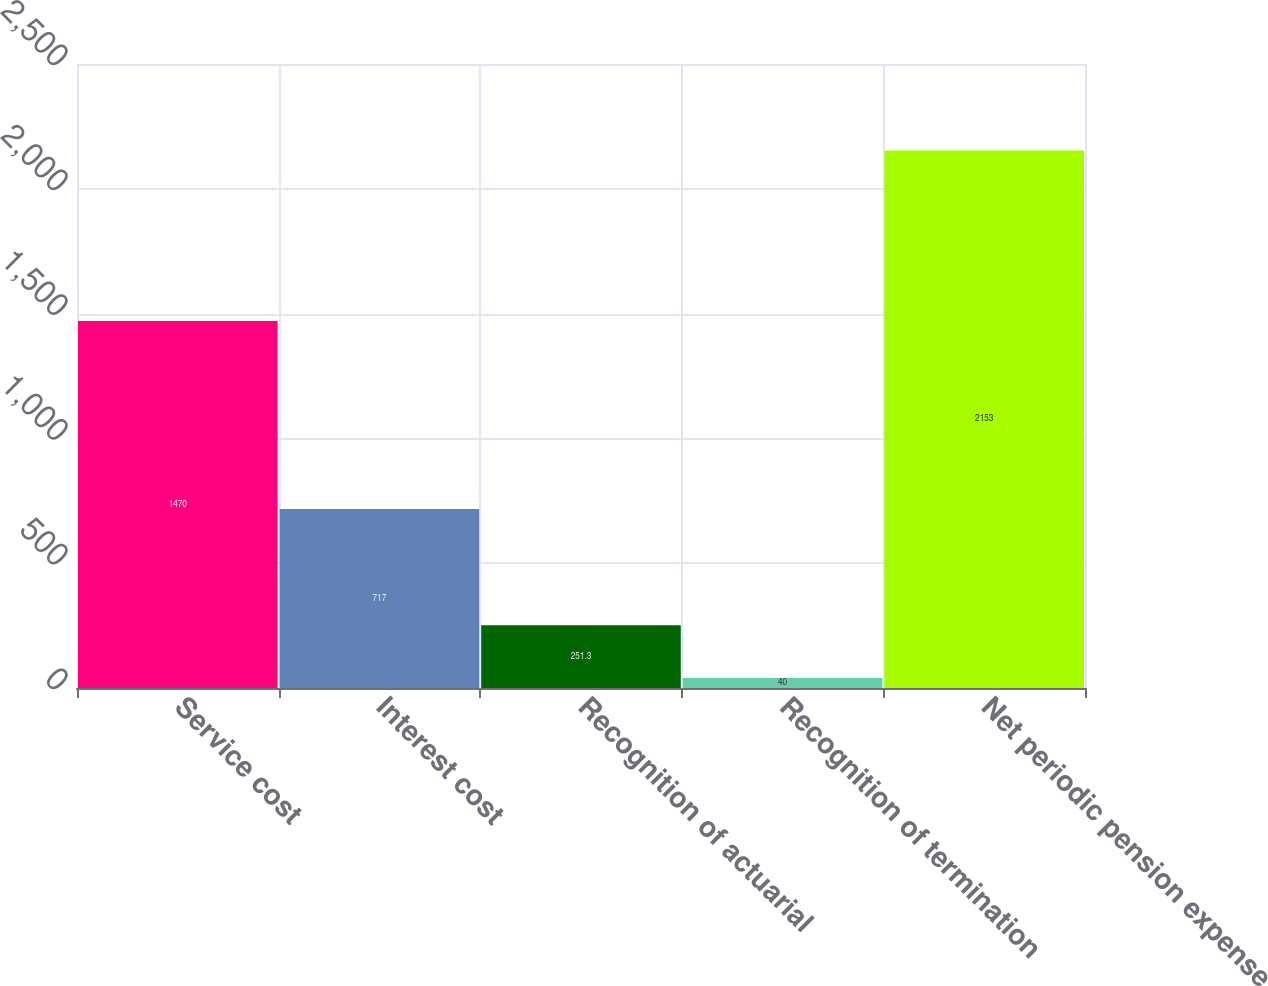Convert chart to OTSL. <chart><loc_0><loc_0><loc_500><loc_500><bar_chart><fcel>Service cost<fcel>Interest cost<fcel>Recognition of actuarial<fcel>Recognition of termination<fcel>Net periodic pension expense<nl><fcel>1470<fcel>717<fcel>251.3<fcel>40<fcel>2153<nl></chart> 